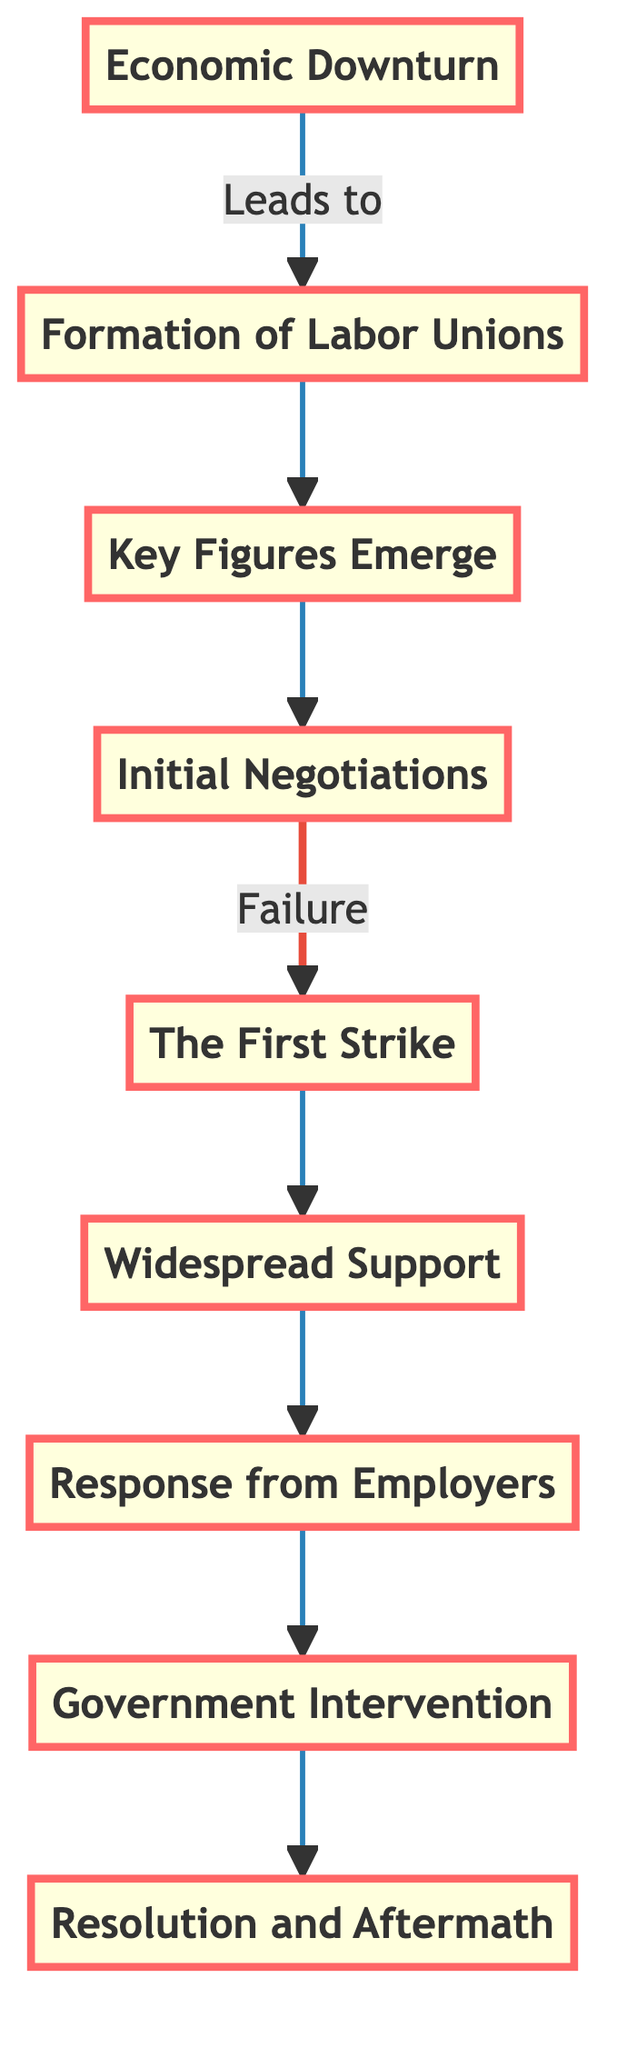What is the first event in the sequence? The diagram starts with "Economic Downturn," which is the first node in the flowchart.
Answer: Economic Downturn How many events are listed in the diagram? There are nine distinct events mentioned in the flowchart, from "Economic Downturn" to "Resolution and Aftermath."
Answer: 9 What event immediately follows the formation of labor unions? The event that follows "Formation of Labor Unions" is "Key Figures Emerge," which is the next node in the flowchart.
Answer: Key Figures Emerge What was the outcome of the initial negotiations? The diagram indicates that the initial negotiations led to a "Failure," as shown by the directed edge from "Initial Negotiations" to "The First Strike."
Answer: Failure Which event leads to government intervention? The event "Response from Employers" leads to "Government Intervention," indicating that the employer's actions resulted in the need for government involvement.
Answer: Response from Employers Which event comes directly before the "Resolution and Aftermath"? "Government Intervention" is the event that comes directly before "Resolution and Aftermath," according to the flow in the diagram.
Answer: Government Intervention How do workers gain broader support during the events? Workers gain broader support through "Widespread Support," which is the event that includes the involvement of workers from other industries joining the dock workers.
Answer: Widespread Support What was the trigger for the first major strike? The trigger for "The First Strike" was the failure of initial negotiations regarding wages and working hours, as stated in the flowchart.
Answer: Initial Negotiations What leads to the formation of labor unions? The "Economic Downturn" is identified as the leading event that necessitated the formation of labor unions, as workers sought better conditions and pay.
Answer: Economic Downturn 